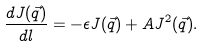Convert formula to latex. <formula><loc_0><loc_0><loc_500><loc_500>\frac { d J ( \vec { q } ) } { d l } = - \epsilon J ( \vec { q } ) + A J ^ { 2 } ( \vec { q } ) .</formula> 